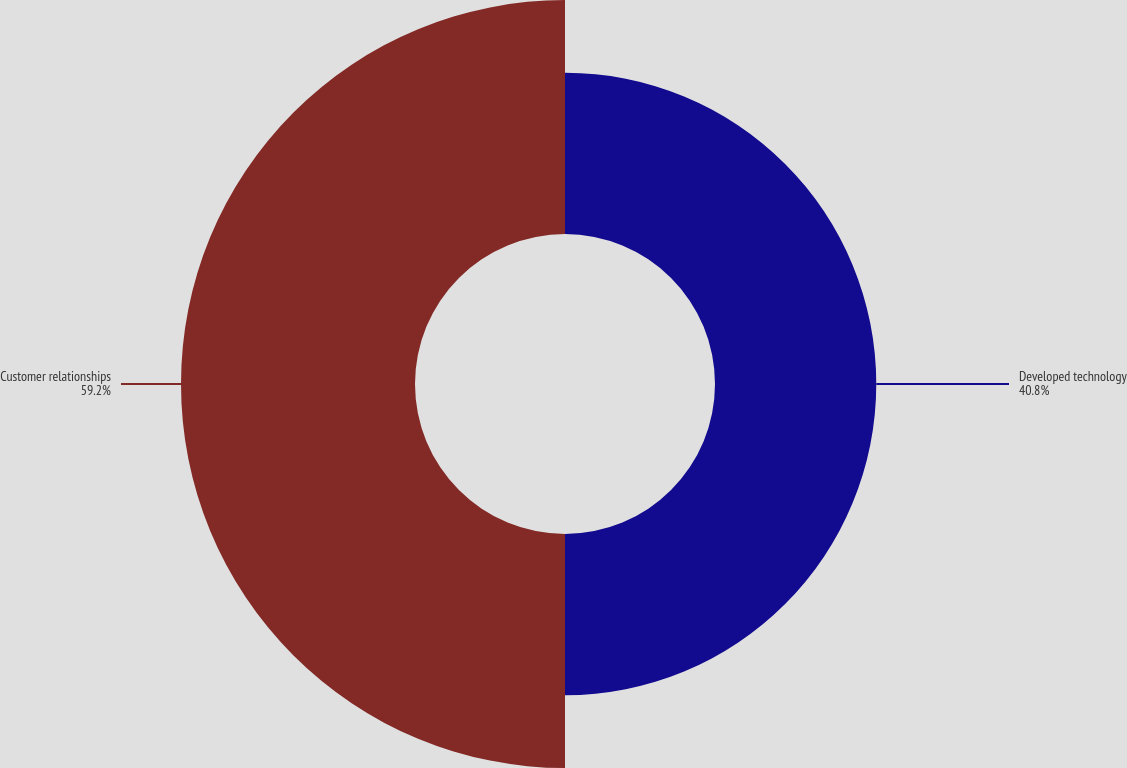Convert chart. <chart><loc_0><loc_0><loc_500><loc_500><pie_chart><fcel>Developed technology<fcel>Customer relationships<nl><fcel>40.8%<fcel>59.2%<nl></chart> 